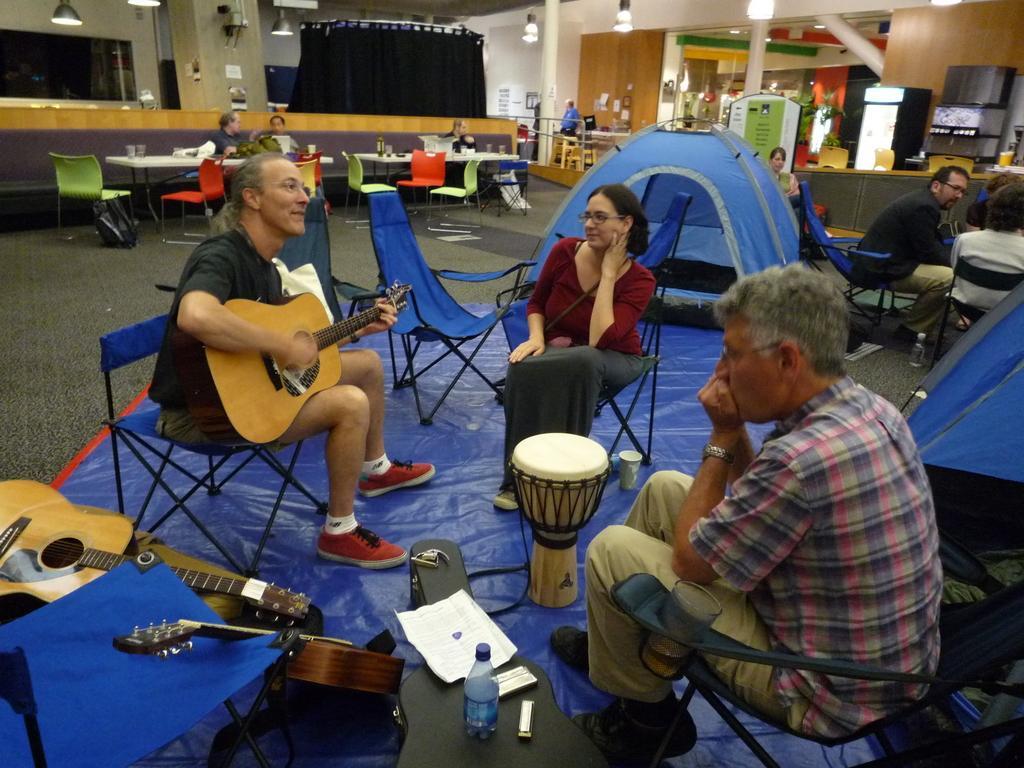Can you describe this image briefly? inside the room there are so many chairs,tables,TV and micro woven and so many things are present in the room and may people are sitting on the chair and some people they talking each other and some person is playing the guitar and also so many instruments are there like guitar,tabla they both are watching the person who is playing the guitar another person they are doing something. 